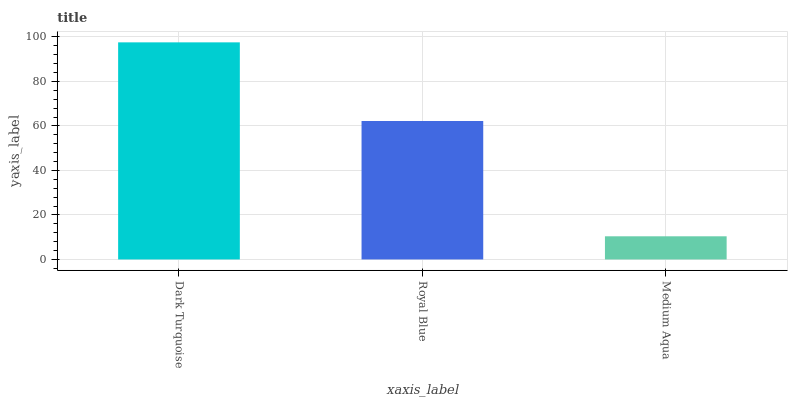Is Medium Aqua the minimum?
Answer yes or no. Yes. Is Dark Turquoise the maximum?
Answer yes or no. Yes. Is Royal Blue the minimum?
Answer yes or no. No. Is Royal Blue the maximum?
Answer yes or no. No. Is Dark Turquoise greater than Royal Blue?
Answer yes or no. Yes. Is Royal Blue less than Dark Turquoise?
Answer yes or no. Yes. Is Royal Blue greater than Dark Turquoise?
Answer yes or no. No. Is Dark Turquoise less than Royal Blue?
Answer yes or no. No. Is Royal Blue the high median?
Answer yes or no. Yes. Is Royal Blue the low median?
Answer yes or no. Yes. Is Medium Aqua the high median?
Answer yes or no. No. Is Medium Aqua the low median?
Answer yes or no. No. 